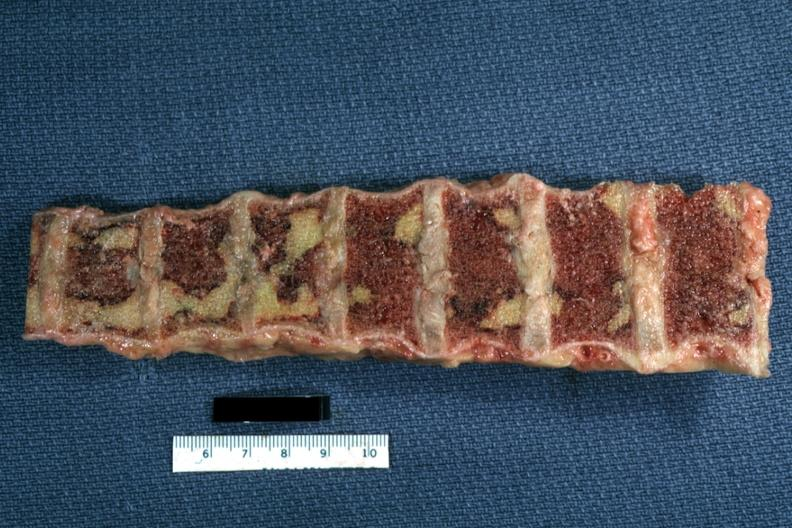how does this image show vertebral bodies?
Answer the question using a single word or phrase. With large necrotic yellow areas case of chronic lymphocytic leukemia progressing to acute lymphocytic leukemia 